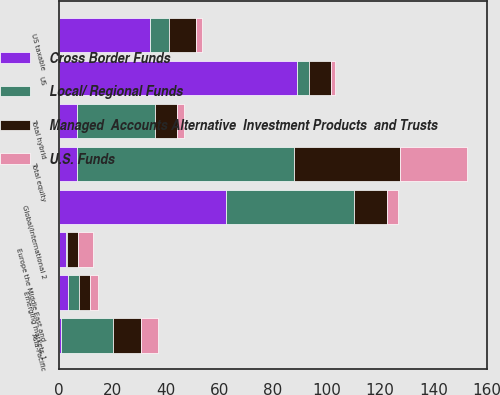Convert chart to OTSL. <chart><loc_0><loc_0><loc_500><loc_500><stacked_bar_chart><ecel><fcel>Asia-Pacific<fcel>Europe the Middle East and<fcel>US<fcel>Emerging markets 1<fcel>Global/international 2<fcel>Total equity<fcel>Total hybrid<fcel>US taxable<nl><fcel>Cross Border Funds<fcel>0.8<fcel>2.5<fcel>89.1<fcel>3.3<fcel>62.3<fcel>6.8<fcel>6.8<fcel>34<nl><fcel>Managed  Accounts Alternative  Investment Products  and Trusts<fcel>10.7<fcel>4.2<fcel>8.3<fcel>4.3<fcel>12.3<fcel>39.8<fcel>8.2<fcel>9.8<nl><fcel>U.S. Funds<fcel>6.4<fcel>5.7<fcel>1.7<fcel>2.9<fcel>4.2<fcel>24.9<fcel>2.6<fcel>2.4<nl><fcel>Local/ Regional Funds<fcel>19.2<fcel>0.3<fcel>4.2<fcel>4.1<fcel>48<fcel>81<fcel>28.9<fcel>7.2<nl></chart> 